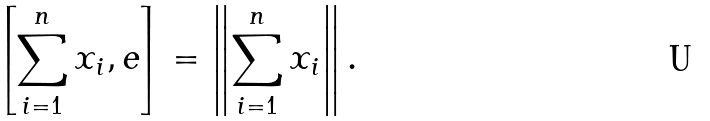<formula> <loc_0><loc_0><loc_500><loc_500>\left [ \sum _ { i = 1 } ^ { n } x _ { i } , e \right ] = \left \| \sum _ { i = 1 } ^ { n } x _ { i } \right \| .</formula> 